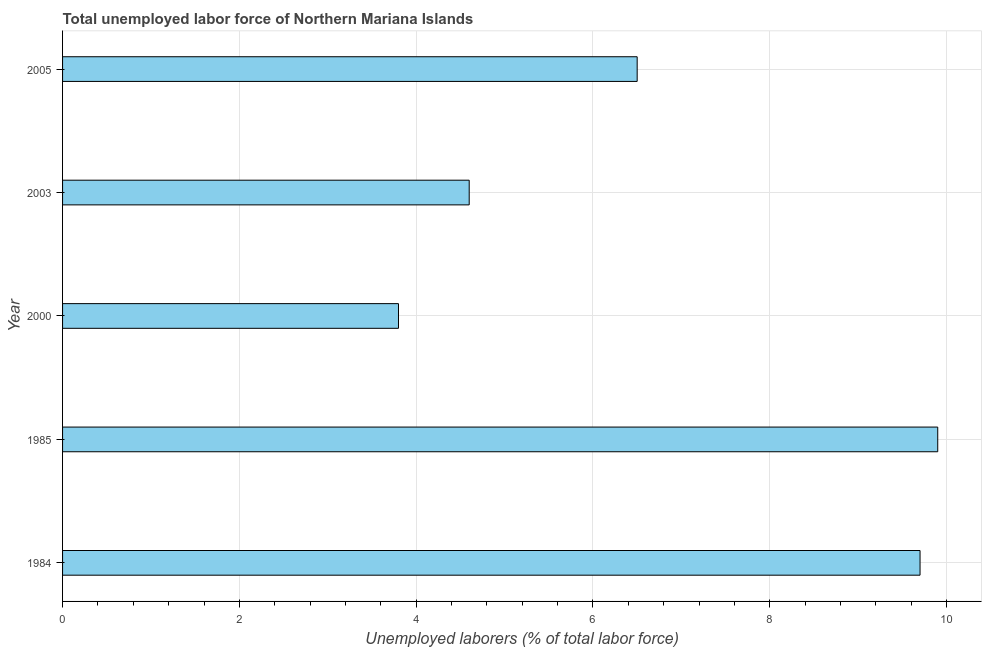Does the graph contain grids?
Keep it short and to the point. Yes. What is the title of the graph?
Make the answer very short. Total unemployed labor force of Northern Mariana Islands. What is the label or title of the X-axis?
Make the answer very short. Unemployed laborers (% of total labor force). What is the total unemployed labour force in 2003?
Your answer should be compact. 4.6. Across all years, what is the maximum total unemployed labour force?
Your answer should be compact. 9.9. Across all years, what is the minimum total unemployed labour force?
Your response must be concise. 3.8. In which year was the total unemployed labour force maximum?
Offer a very short reply. 1985. What is the sum of the total unemployed labour force?
Your answer should be very brief. 34.5. What is the average total unemployed labour force per year?
Offer a terse response. 6.9. What is the median total unemployed labour force?
Provide a short and direct response. 6.5. What is the ratio of the total unemployed labour force in 2000 to that in 2005?
Give a very brief answer. 0.58. Is the total unemployed labour force in 2000 less than that in 2005?
Offer a terse response. Yes. Is the difference between the total unemployed labour force in 1985 and 2000 greater than the difference between any two years?
Ensure brevity in your answer.  Yes. What is the difference between the highest and the second highest total unemployed labour force?
Offer a very short reply. 0.2. Is the sum of the total unemployed labour force in 1984 and 1985 greater than the maximum total unemployed labour force across all years?
Keep it short and to the point. Yes. How many bars are there?
Your answer should be compact. 5. Are all the bars in the graph horizontal?
Provide a short and direct response. Yes. How many years are there in the graph?
Provide a succinct answer. 5. What is the Unemployed laborers (% of total labor force) of 1984?
Your answer should be very brief. 9.7. What is the Unemployed laborers (% of total labor force) in 1985?
Provide a succinct answer. 9.9. What is the Unemployed laborers (% of total labor force) of 2000?
Keep it short and to the point. 3.8. What is the Unemployed laborers (% of total labor force) of 2003?
Keep it short and to the point. 4.6. What is the difference between the Unemployed laborers (% of total labor force) in 1984 and 1985?
Give a very brief answer. -0.2. What is the difference between the Unemployed laborers (% of total labor force) in 1984 and 2000?
Keep it short and to the point. 5.9. What is the ratio of the Unemployed laborers (% of total labor force) in 1984 to that in 2000?
Keep it short and to the point. 2.55. What is the ratio of the Unemployed laborers (% of total labor force) in 1984 to that in 2003?
Provide a succinct answer. 2.11. What is the ratio of the Unemployed laborers (% of total labor force) in 1984 to that in 2005?
Offer a very short reply. 1.49. What is the ratio of the Unemployed laborers (% of total labor force) in 1985 to that in 2000?
Your answer should be very brief. 2.6. What is the ratio of the Unemployed laborers (% of total labor force) in 1985 to that in 2003?
Keep it short and to the point. 2.15. What is the ratio of the Unemployed laborers (% of total labor force) in 1985 to that in 2005?
Provide a short and direct response. 1.52. What is the ratio of the Unemployed laborers (% of total labor force) in 2000 to that in 2003?
Your response must be concise. 0.83. What is the ratio of the Unemployed laborers (% of total labor force) in 2000 to that in 2005?
Offer a terse response. 0.58. What is the ratio of the Unemployed laborers (% of total labor force) in 2003 to that in 2005?
Offer a very short reply. 0.71. 